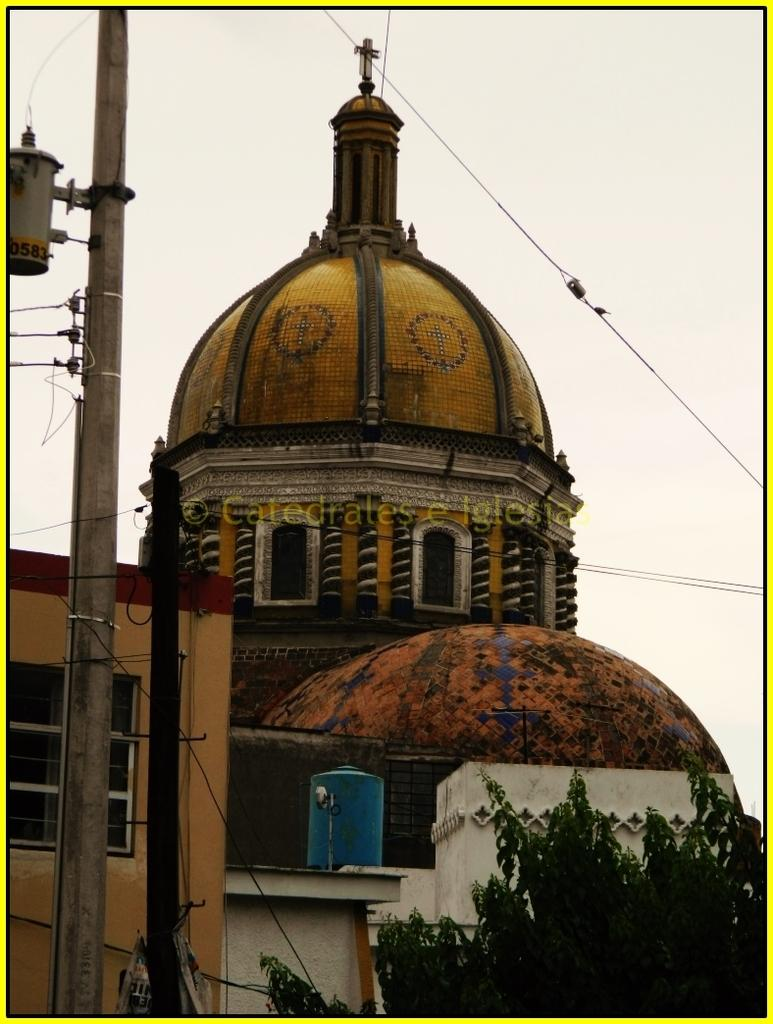What type of structures can be seen in the image? There are buildings in the image. What natural element is present in the image? There is a tree in the image. What man-made objects can be seen in the image? There are poles in the image. How would you describe the weather in the image? The sky is cloudy in the image. What type of cracker is being offered as advice in the image? There is no cracker or advice present in the image. What kind of hat is being worn by the tree in the image? There is no hat present in the image, as it features a tree and not a person or animal. 